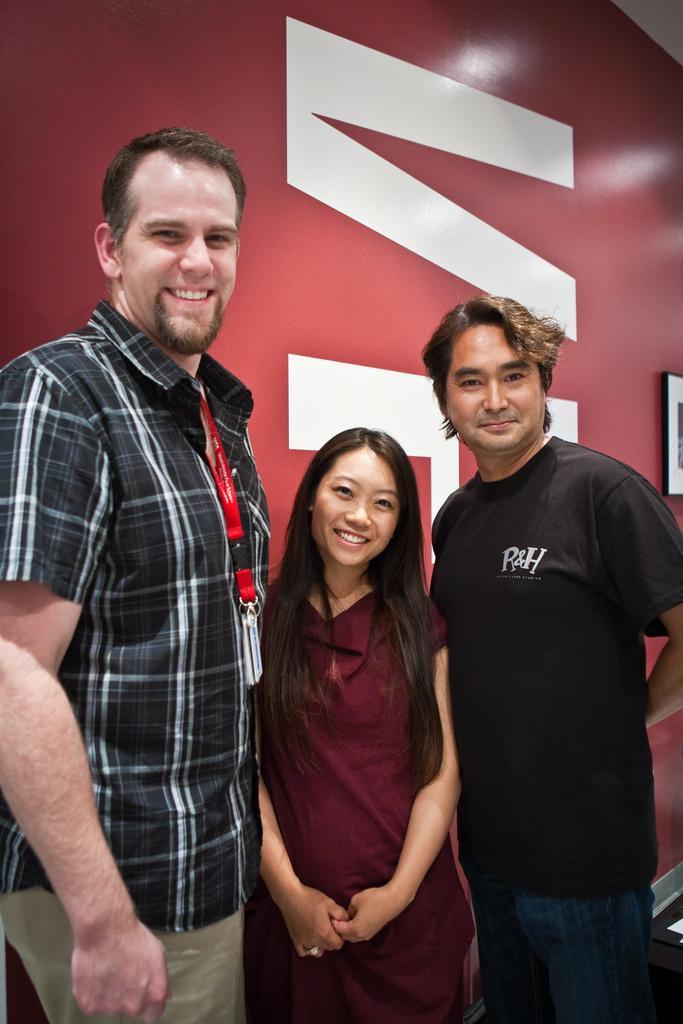Please provide a concise description of this image. In this picture we can see there are three people standing and behind the people there is a wall with a frame. 